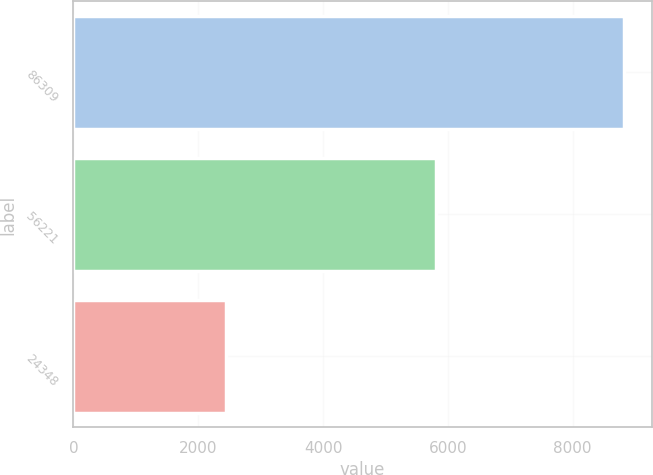Convert chart to OTSL. <chart><loc_0><loc_0><loc_500><loc_500><bar_chart><fcel>86309<fcel>56221<fcel>24348<nl><fcel>8822.9<fcel>5806.4<fcel>2443.2<nl></chart> 